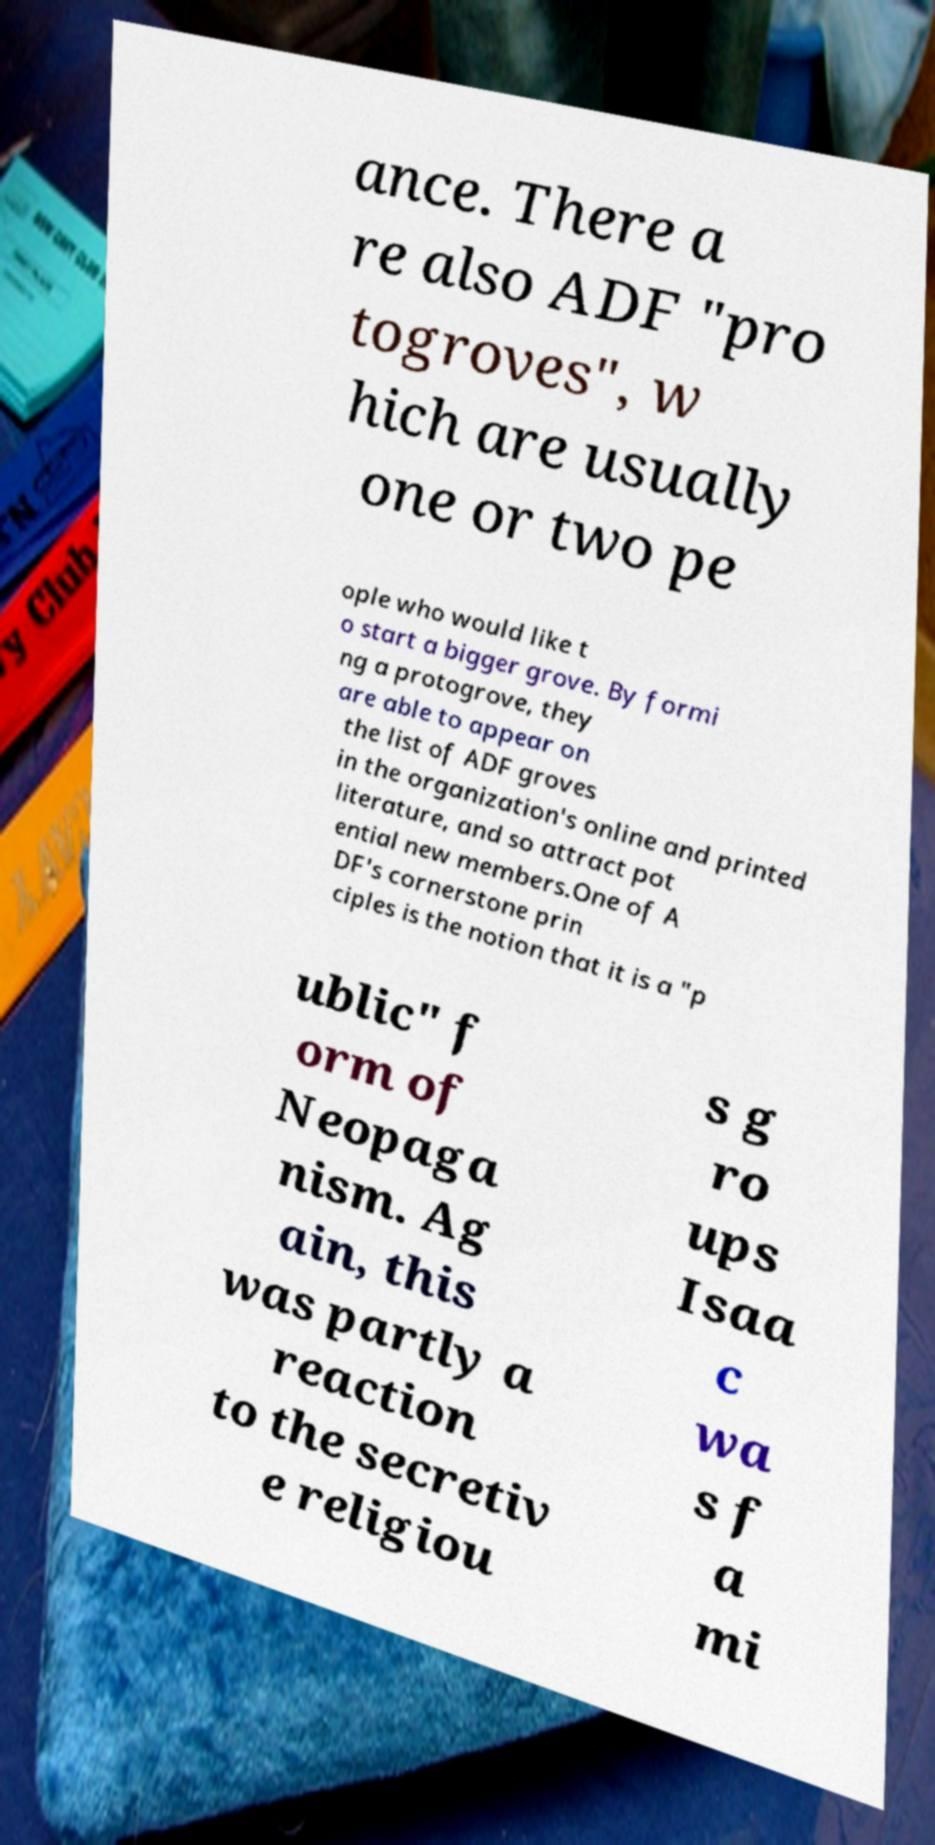Please read and relay the text visible in this image. What does it say? ance. There a re also ADF "pro togroves", w hich are usually one or two pe ople who would like t o start a bigger grove. By formi ng a protogrove, they are able to appear on the list of ADF groves in the organization's online and printed literature, and so attract pot ential new members.One of A DF's cornerstone prin ciples is the notion that it is a "p ublic" f orm of Neopaga nism. Ag ain, this was partly a reaction to the secretiv e religiou s g ro ups Isaa c wa s f a mi 